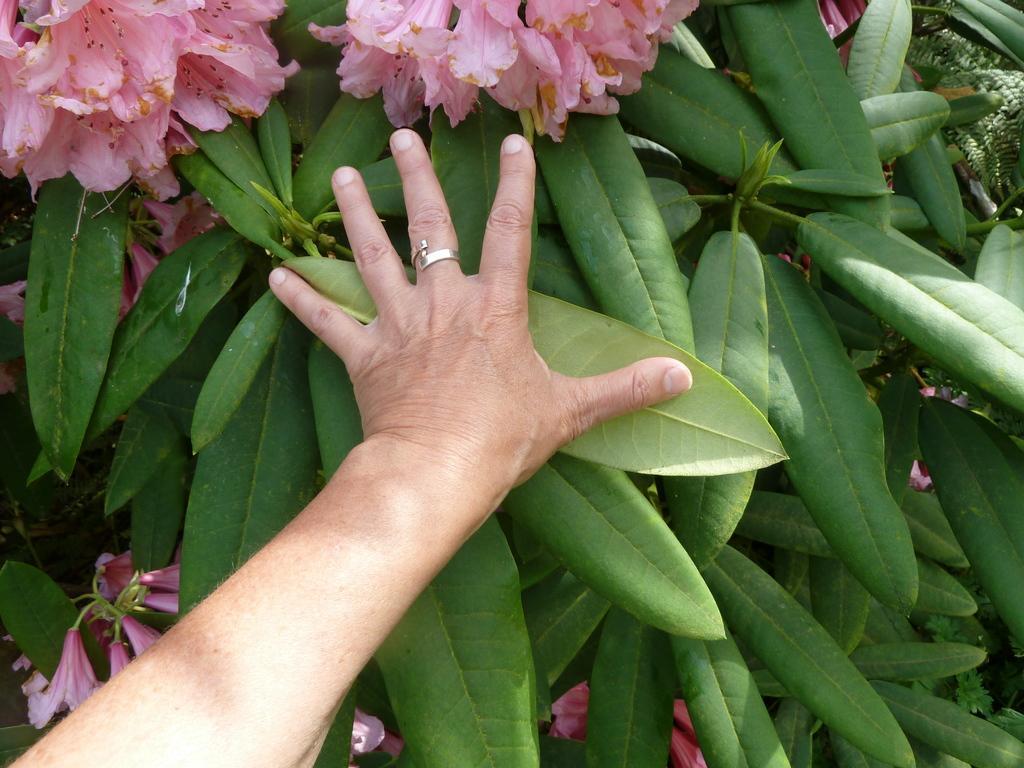Could you give a brief overview of what you see in this image? In this picture we can see a person's hand, leaves and flowers. 